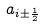Convert formula to latex. <formula><loc_0><loc_0><loc_500><loc_500>a _ { i \pm \frac { 1 } { 2 } }</formula> 